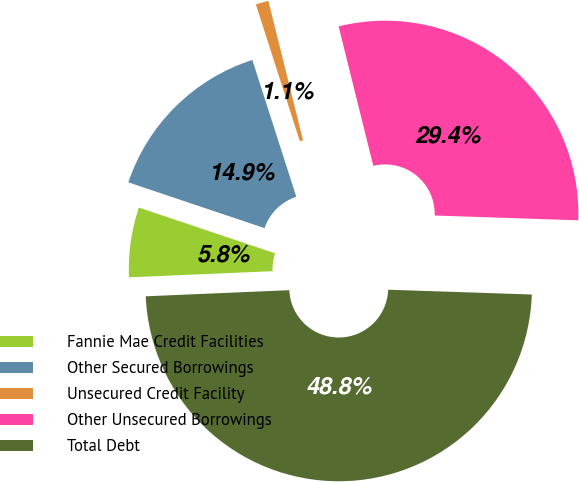Convert chart to OTSL. <chart><loc_0><loc_0><loc_500><loc_500><pie_chart><fcel>Fannie Mae Credit Facilities<fcel>Other Secured Borrowings<fcel>Unsecured Credit Facility<fcel>Other Unsecured Borrowings<fcel>Total Debt<nl><fcel>5.84%<fcel>14.89%<fcel>1.07%<fcel>29.41%<fcel>48.79%<nl></chart> 